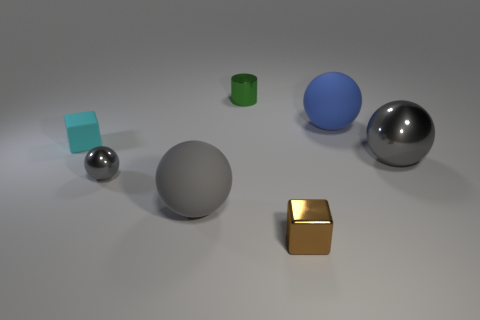What number of other things are there of the same material as the cylinder
Make the answer very short. 3. What is the size of the shiny ball that is right of the gray matte object?
Provide a short and direct response. Large. There is another small thing that is made of the same material as the blue thing; what shape is it?
Your response must be concise. Cube. Does the big blue sphere have the same material as the cube behind the small brown block?
Your answer should be compact. Yes. Does the gray metal thing that is on the left side of the brown metal cube have the same shape as the big metallic object?
Your answer should be very brief. Yes. There is another large gray thing that is the same shape as the large gray shiny thing; what material is it?
Your answer should be very brief. Rubber. There is a large blue thing; is its shape the same as the gray metal thing that is right of the brown block?
Make the answer very short. Yes. What color is the large thing that is both to the right of the small cylinder and in front of the blue thing?
Your response must be concise. Gray. Is there a brown cube?
Offer a very short reply. Yes. Are there an equal number of gray balls that are to the right of the big metal ball and tiny green shiny cylinders?
Ensure brevity in your answer.  No. 